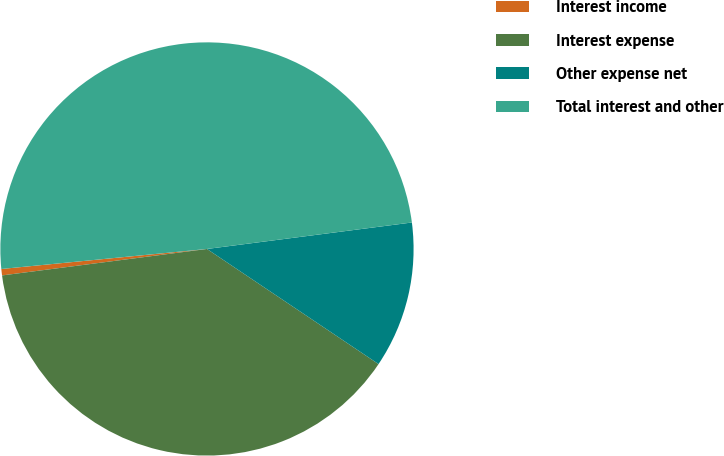Convert chart to OTSL. <chart><loc_0><loc_0><loc_500><loc_500><pie_chart><fcel>Interest income<fcel>Interest expense<fcel>Other expense net<fcel>Total interest and other<nl><fcel>0.5%<fcel>38.55%<fcel>11.45%<fcel>49.5%<nl></chart> 